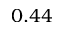Convert formula to latex. <formula><loc_0><loc_0><loc_500><loc_500>0 . 4 4</formula> 